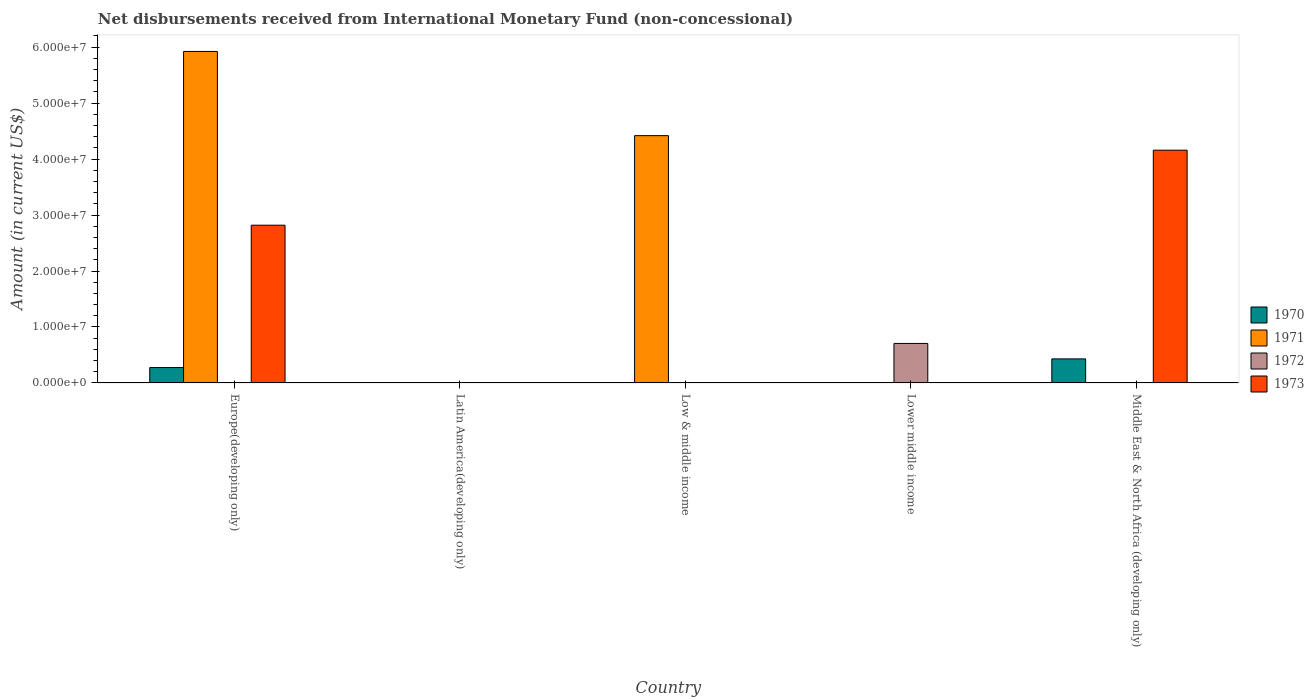How many different coloured bars are there?
Keep it short and to the point. 4. Are the number of bars per tick equal to the number of legend labels?
Keep it short and to the point. No. How many bars are there on the 5th tick from the right?
Provide a succinct answer. 3. What is the label of the 5th group of bars from the left?
Provide a short and direct response. Middle East & North Africa (developing only). In how many cases, is the number of bars for a given country not equal to the number of legend labels?
Provide a short and direct response. 5. What is the amount of disbursements received from International Monetary Fund in 1970 in Europe(developing only)?
Give a very brief answer. 2.75e+06. Across all countries, what is the maximum amount of disbursements received from International Monetary Fund in 1973?
Your response must be concise. 4.16e+07. Across all countries, what is the minimum amount of disbursements received from International Monetary Fund in 1970?
Your answer should be compact. 0. In which country was the amount of disbursements received from International Monetary Fund in 1970 maximum?
Offer a very short reply. Middle East & North Africa (developing only). What is the total amount of disbursements received from International Monetary Fund in 1972 in the graph?
Give a very brief answer. 7.06e+06. What is the difference between the amount of disbursements received from International Monetary Fund in 1973 in Europe(developing only) and that in Middle East & North Africa (developing only)?
Keep it short and to the point. -1.34e+07. What is the difference between the amount of disbursements received from International Monetary Fund in 1972 in Low & middle income and the amount of disbursements received from International Monetary Fund in 1971 in Europe(developing only)?
Provide a succinct answer. -5.92e+07. What is the average amount of disbursements received from International Monetary Fund in 1972 per country?
Provide a short and direct response. 1.41e+06. In how many countries, is the amount of disbursements received from International Monetary Fund in 1972 greater than 8000000 US$?
Your answer should be compact. 0. What is the difference between the highest and the lowest amount of disbursements received from International Monetary Fund in 1971?
Make the answer very short. 5.92e+07. In how many countries, is the amount of disbursements received from International Monetary Fund in 1970 greater than the average amount of disbursements received from International Monetary Fund in 1970 taken over all countries?
Keep it short and to the point. 2. Is the sum of the amount of disbursements received from International Monetary Fund in 1971 in Europe(developing only) and Low & middle income greater than the maximum amount of disbursements received from International Monetary Fund in 1973 across all countries?
Your answer should be very brief. Yes. Are all the bars in the graph horizontal?
Your answer should be very brief. No. How many countries are there in the graph?
Keep it short and to the point. 5. What is the difference between two consecutive major ticks on the Y-axis?
Ensure brevity in your answer.  1.00e+07. Are the values on the major ticks of Y-axis written in scientific E-notation?
Offer a very short reply. Yes. Does the graph contain any zero values?
Provide a short and direct response. Yes. Where does the legend appear in the graph?
Ensure brevity in your answer.  Center right. How are the legend labels stacked?
Make the answer very short. Vertical. What is the title of the graph?
Offer a terse response. Net disbursements received from International Monetary Fund (non-concessional). What is the label or title of the X-axis?
Offer a very short reply. Country. What is the Amount (in current US$) of 1970 in Europe(developing only)?
Offer a very short reply. 2.75e+06. What is the Amount (in current US$) of 1971 in Europe(developing only)?
Ensure brevity in your answer.  5.92e+07. What is the Amount (in current US$) in 1972 in Europe(developing only)?
Provide a succinct answer. 0. What is the Amount (in current US$) in 1973 in Europe(developing only)?
Offer a terse response. 2.82e+07. What is the Amount (in current US$) of 1970 in Latin America(developing only)?
Provide a short and direct response. 0. What is the Amount (in current US$) in 1971 in Latin America(developing only)?
Ensure brevity in your answer.  0. What is the Amount (in current US$) in 1973 in Latin America(developing only)?
Offer a very short reply. 0. What is the Amount (in current US$) of 1970 in Low & middle income?
Ensure brevity in your answer.  0. What is the Amount (in current US$) of 1971 in Low & middle income?
Offer a terse response. 4.42e+07. What is the Amount (in current US$) in 1971 in Lower middle income?
Your answer should be compact. 0. What is the Amount (in current US$) of 1972 in Lower middle income?
Give a very brief answer. 7.06e+06. What is the Amount (in current US$) of 1973 in Lower middle income?
Make the answer very short. 0. What is the Amount (in current US$) of 1970 in Middle East & North Africa (developing only)?
Provide a short and direct response. 4.30e+06. What is the Amount (in current US$) of 1971 in Middle East & North Africa (developing only)?
Give a very brief answer. 0. What is the Amount (in current US$) of 1972 in Middle East & North Africa (developing only)?
Your answer should be compact. 0. What is the Amount (in current US$) in 1973 in Middle East & North Africa (developing only)?
Your response must be concise. 4.16e+07. Across all countries, what is the maximum Amount (in current US$) in 1970?
Make the answer very short. 4.30e+06. Across all countries, what is the maximum Amount (in current US$) in 1971?
Your answer should be very brief. 5.92e+07. Across all countries, what is the maximum Amount (in current US$) in 1972?
Make the answer very short. 7.06e+06. Across all countries, what is the maximum Amount (in current US$) in 1973?
Make the answer very short. 4.16e+07. Across all countries, what is the minimum Amount (in current US$) of 1970?
Your answer should be compact. 0. What is the total Amount (in current US$) of 1970 in the graph?
Your response must be concise. 7.05e+06. What is the total Amount (in current US$) of 1971 in the graph?
Offer a very short reply. 1.03e+08. What is the total Amount (in current US$) of 1972 in the graph?
Give a very brief answer. 7.06e+06. What is the total Amount (in current US$) in 1973 in the graph?
Give a very brief answer. 6.98e+07. What is the difference between the Amount (in current US$) in 1971 in Europe(developing only) and that in Low & middle income?
Keep it short and to the point. 1.50e+07. What is the difference between the Amount (in current US$) of 1970 in Europe(developing only) and that in Middle East & North Africa (developing only)?
Make the answer very short. -1.55e+06. What is the difference between the Amount (in current US$) of 1973 in Europe(developing only) and that in Middle East & North Africa (developing only)?
Keep it short and to the point. -1.34e+07. What is the difference between the Amount (in current US$) of 1970 in Europe(developing only) and the Amount (in current US$) of 1971 in Low & middle income?
Offer a terse response. -4.14e+07. What is the difference between the Amount (in current US$) of 1970 in Europe(developing only) and the Amount (in current US$) of 1972 in Lower middle income?
Your response must be concise. -4.31e+06. What is the difference between the Amount (in current US$) in 1971 in Europe(developing only) and the Amount (in current US$) in 1972 in Lower middle income?
Your response must be concise. 5.22e+07. What is the difference between the Amount (in current US$) in 1970 in Europe(developing only) and the Amount (in current US$) in 1973 in Middle East & North Africa (developing only)?
Your response must be concise. -3.88e+07. What is the difference between the Amount (in current US$) of 1971 in Europe(developing only) and the Amount (in current US$) of 1973 in Middle East & North Africa (developing only)?
Your answer should be very brief. 1.76e+07. What is the difference between the Amount (in current US$) in 1971 in Low & middle income and the Amount (in current US$) in 1972 in Lower middle income?
Make the answer very short. 3.71e+07. What is the difference between the Amount (in current US$) in 1971 in Low & middle income and the Amount (in current US$) in 1973 in Middle East & North Africa (developing only)?
Make the answer very short. 2.60e+06. What is the difference between the Amount (in current US$) in 1972 in Lower middle income and the Amount (in current US$) in 1973 in Middle East & North Africa (developing only)?
Your answer should be compact. -3.45e+07. What is the average Amount (in current US$) in 1970 per country?
Make the answer very short. 1.41e+06. What is the average Amount (in current US$) of 1971 per country?
Offer a very short reply. 2.07e+07. What is the average Amount (in current US$) of 1972 per country?
Ensure brevity in your answer.  1.41e+06. What is the average Amount (in current US$) in 1973 per country?
Keep it short and to the point. 1.40e+07. What is the difference between the Amount (in current US$) in 1970 and Amount (in current US$) in 1971 in Europe(developing only)?
Your answer should be very brief. -5.65e+07. What is the difference between the Amount (in current US$) in 1970 and Amount (in current US$) in 1973 in Europe(developing only)?
Your answer should be very brief. -2.54e+07. What is the difference between the Amount (in current US$) of 1971 and Amount (in current US$) of 1973 in Europe(developing only)?
Offer a very short reply. 3.10e+07. What is the difference between the Amount (in current US$) of 1970 and Amount (in current US$) of 1973 in Middle East & North Africa (developing only)?
Offer a very short reply. -3.73e+07. What is the ratio of the Amount (in current US$) of 1971 in Europe(developing only) to that in Low & middle income?
Your answer should be very brief. 1.34. What is the ratio of the Amount (in current US$) of 1970 in Europe(developing only) to that in Middle East & North Africa (developing only)?
Offer a very short reply. 0.64. What is the ratio of the Amount (in current US$) of 1973 in Europe(developing only) to that in Middle East & North Africa (developing only)?
Your answer should be very brief. 0.68. What is the difference between the highest and the lowest Amount (in current US$) of 1970?
Offer a very short reply. 4.30e+06. What is the difference between the highest and the lowest Amount (in current US$) in 1971?
Your answer should be compact. 5.92e+07. What is the difference between the highest and the lowest Amount (in current US$) in 1972?
Ensure brevity in your answer.  7.06e+06. What is the difference between the highest and the lowest Amount (in current US$) of 1973?
Your answer should be very brief. 4.16e+07. 